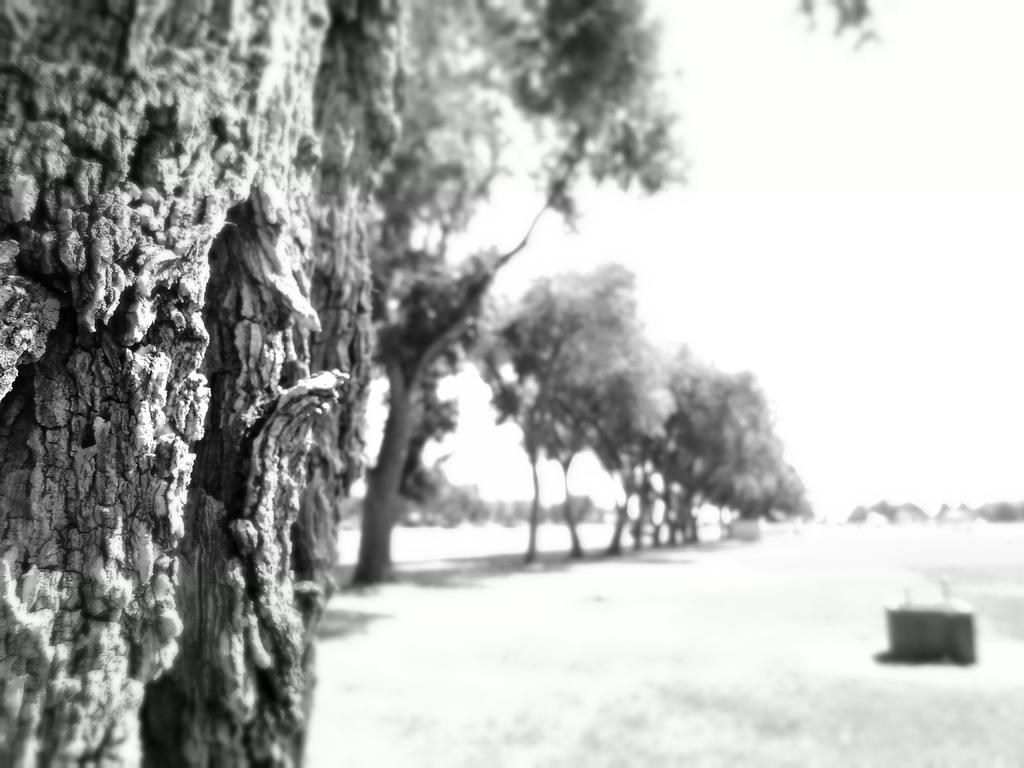Can you describe this image briefly? This is a black and white picture, in this image we can see some trees and an object on the ground, in the background we can see the sky. 